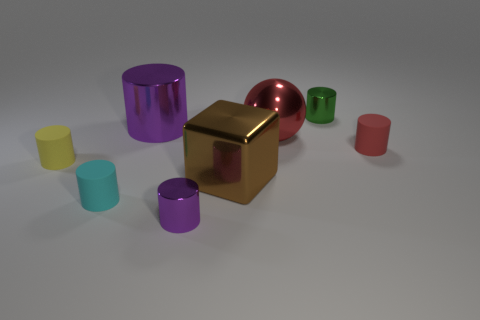Is there a metallic sphere that has the same size as the cyan cylinder?
Your answer should be compact. No. There is a purple cylinder that is the same size as the block; what is its material?
Your response must be concise. Metal. What is the shape of the rubber object that is in front of the yellow cylinder?
Offer a very short reply. Cylinder. Is the purple object that is behind the cyan matte object made of the same material as the red thing in front of the large red ball?
Keep it short and to the point. No. What number of other tiny red things have the same shape as the red metal object?
Your answer should be very brief. 0. There is a small object that is the same color as the big shiny ball; what is its material?
Keep it short and to the point. Rubber. How many things are either tiny green metallic objects or tiny rubber cylinders that are to the left of the small green cylinder?
Your response must be concise. 3. What material is the big sphere?
Ensure brevity in your answer.  Metal. There is a large object that is the same shape as the tiny green thing; what is its material?
Keep it short and to the point. Metal. There is a object that is on the left side of the tiny cyan rubber thing in front of the large purple shiny cylinder; what color is it?
Ensure brevity in your answer.  Yellow. 